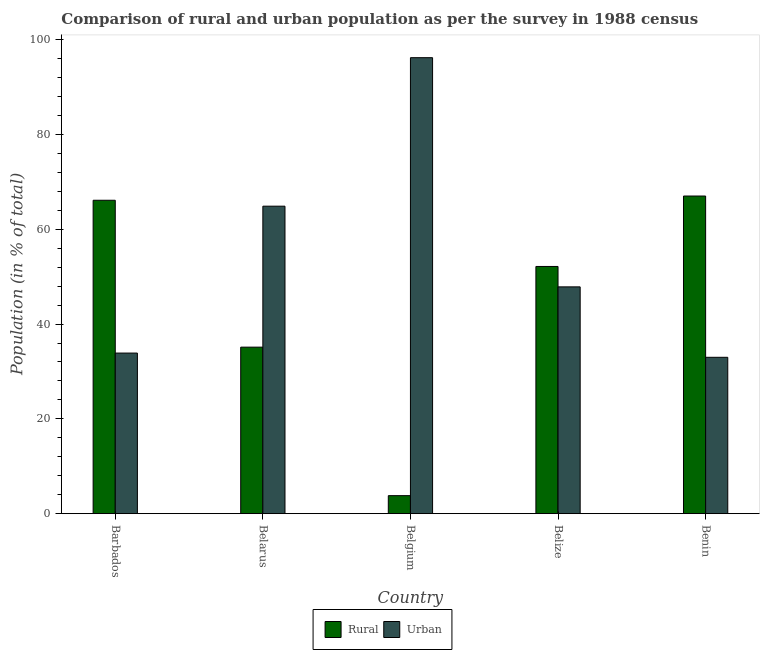How many different coloured bars are there?
Offer a very short reply. 2. How many groups of bars are there?
Provide a short and direct response. 5. What is the label of the 5th group of bars from the left?
Ensure brevity in your answer.  Benin. In how many cases, is the number of bars for a given country not equal to the number of legend labels?
Keep it short and to the point. 0. What is the rural population in Belarus?
Offer a terse response. 35.13. Across all countries, what is the maximum urban population?
Give a very brief answer. 96.2. Across all countries, what is the minimum urban population?
Your response must be concise. 32.98. In which country was the urban population maximum?
Give a very brief answer. Belgium. In which country was the urban population minimum?
Make the answer very short. Benin. What is the total urban population in the graph?
Give a very brief answer. 275.79. What is the difference between the urban population in Belize and that in Benin?
Make the answer very short. 14.86. What is the difference between the urban population in Belgium and the rural population in Barbados?
Provide a succinct answer. 30.08. What is the average urban population per country?
Your response must be concise. 55.16. What is the difference between the rural population and urban population in Belize?
Provide a short and direct response. 4.31. What is the ratio of the urban population in Belgium to that in Belize?
Make the answer very short. 2.01. Is the urban population in Belarus less than that in Belize?
Your answer should be very brief. No. What is the difference between the highest and the second highest urban population?
Keep it short and to the point. 31.33. What is the difference between the highest and the lowest rural population?
Ensure brevity in your answer.  63.22. Is the sum of the rural population in Belarus and Belize greater than the maximum urban population across all countries?
Ensure brevity in your answer.  No. What does the 1st bar from the left in Benin represents?
Offer a terse response. Rural. What does the 1st bar from the right in Barbados represents?
Give a very brief answer. Urban. What is the difference between two consecutive major ticks on the Y-axis?
Your answer should be very brief. 20. Does the graph contain any zero values?
Offer a very short reply. No. Does the graph contain grids?
Give a very brief answer. No. How many legend labels are there?
Your response must be concise. 2. How are the legend labels stacked?
Offer a very short reply. Horizontal. What is the title of the graph?
Give a very brief answer. Comparison of rural and urban population as per the survey in 1988 census. Does "Resident workers" appear as one of the legend labels in the graph?
Give a very brief answer. No. What is the label or title of the Y-axis?
Give a very brief answer. Population (in % of total). What is the Population (in % of total) in Rural in Barbados?
Keep it short and to the point. 66.12. What is the Population (in % of total) in Urban in Barbados?
Offer a terse response. 33.88. What is the Population (in % of total) of Rural in Belarus?
Provide a succinct answer. 35.13. What is the Population (in % of total) in Urban in Belarus?
Make the answer very short. 64.87. What is the Population (in % of total) in Rural in Belgium?
Make the answer very short. 3.8. What is the Population (in % of total) of Urban in Belgium?
Offer a terse response. 96.2. What is the Population (in % of total) of Rural in Belize?
Offer a terse response. 52.15. What is the Population (in % of total) of Urban in Belize?
Keep it short and to the point. 47.85. What is the Population (in % of total) in Rural in Benin?
Your answer should be very brief. 67.02. What is the Population (in % of total) of Urban in Benin?
Your answer should be very brief. 32.98. Across all countries, what is the maximum Population (in % of total) in Rural?
Provide a short and direct response. 67.02. Across all countries, what is the maximum Population (in % of total) in Urban?
Offer a terse response. 96.2. Across all countries, what is the minimum Population (in % of total) of Rural?
Your response must be concise. 3.8. Across all countries, what is the minimum Population (in % of total) in Urban?
Offer a terse response. 32.98. What is the total Population (in % of total) of Rural in the graph?
Keep it short and to the point. 224.21. What is the total Population (in % of total) of Urban in the graph?
Offer a terse response. 275.79. What is the difference between the Population (in % of total) in Rural in Barbados and that in Belarus?
Your response must be concise. 30.99. What is the difference between the Population (in % of total) of Urban in Barbados and that in Belarus?
Your answer should be compact. -30.99. What is the difference between the Population (in % of total) in Rural in Barbados and that in Belgium?
Keep it short and to the point. 62.32. What is the difference between the Population (in % of total) of Urban in Barbados and that in Belgium?
Your answer should be compact. -62.32. What is the difference between the Population (in % of total) of Rural in Barbados and that in Belize?
Your answer should be very brief. 13.97. What is the difference between the Population (in % of total) in Urban in Barbados and that in Belize?
Offer a very short reply. -13.97. What is the difference between the Population (in % of total) of Rural in Barbados and that in Benin?
Your answer should be compact. -0.9. What is the difference between the Population (in % of total) in Urban in Barbados and that in Benin?
Give a very brief answer. 0.9. What is the difference between the Population (in % of total) of Rural in Belarus and that in Belgium?
Give a very brief answer. 31.33. What is the difference between the Population (in % of total) of Urban in Belarus and that in Belgium?
Ensure brevity in your answer.  -31.33. What is the difference between the Population (in % of total) in Rural in Belarus and that in Belize?
Your answer should be compact. -17.03. What is the difference between the Population (in % of total) in Urban in Belarus and that in Belize?
Keep it short and to the point. 17.03. What is the difference between the Population (in % of total) in Rural in Belarus and that in Benin?
Make the answer very short. -31.89. What is the difference between the Population (in % of total) of Urban in Belarus and that in Benin?
Ensure brevity in your answer.  31.89. What is the difference between the Population (in % of total) of Rural in Belgium and that in Belize?
Make the answer very short. -48.36. What is the difference between the Population (in % of total) in Urban in Belgium and that in Belize?
Provide a succinct answer. 48.36. What is the difference between the Population (in % of total) of Rural in Belgium and that in Benin?
Give a very brief answer. -63.22. What is the difference between the Population (in % of total) in Urban in Belgium and that in Benin?
Offer a terse response. 63.22. What is the difference between the Population (in % of total) in Rural in Belize and that in Benin?
Provide a short and direct response. -14.86. What is the difference between the Population (in % of total) in Urban in Belize and that in Benin?
Give a very brief answer. 14.86. What is the difference between the Population (in % of total) in Rural in Barbados and the Population (in % of total) in Urban in Belarus?
Make the answer very short. 1.25. What is the difference between the Population (in % of total) of Rural in Barbados and the Population (in % of total) of Urban in Belgium?
Offer a terse response. -30.08. What is the difference between the Population (in % of total) in Rural in Barbados and the Population (in % of total) in Urban in Belize?
Give a very brief answer. 18.27. What is the difference between the Population (in % of total) in Rural in Barbados and the Population (in % of total) in Urban in Benin?
Your response must be concise. 33.13. What is the difference between the Population (in % of total) of Rural in Belarus and the Population (in % of total) of Urban in Belgium?
Provide a succinct answer. -61.08. What is the difference between the Population (in % of total) in Rural in Belarus and the Population (in % of total) in Urban in Belize?
Offer a terse response. -12.72. What is the difference between the Population (in % of total) in Rural in Belarus and the Population (in % of total) in Urban in Benin?
Provide a short and direct response. 2.14. What is the difference between the Population (in % of total) of Rural in Belgium and the Population (in % of total) of Urban in Belize?
Offer a very short reply. -44.05. What is the difference between the Population (in % of total) of Rural in Belgium and the Population (in % of total) of Urban in Benin?
Give a very brief answer. -29.19. What is the difference between the Population (in % of total) in Rural in Belize and the Population (in % of total) in Urban in Benin?
Make the answer very short. 19.17. What is the average Population (in % of total) in Rural per country?
Ensure brevity in your answer.  44.84. What is the average Population (in % of total) of Urban per country?
Your answer should be very brief. 55.16. What is the difference between the Population (in % of total) in Rural and Population (in % of total) in Urban in Barbados?
Offer a terse response. 32.24. What is the difference between the Population (in % of total) of Rural and Population (in % of total) of Urban in Belarus?
Provide a short and direct response. -29.74. What is the difference between the Population (in % of total) in Rural and Population (in % of total) in Urban in Belgium?
Ensure brevity in your answer.  -92.41. What is the difference between the Population (in % of total) in Rural and Population (in % of total) in Urban in Belize?
Your answer should be compact. 4.31. What is the difference between the Population (in % of total) in Rural and Population (in % of total) in Urban in Benin?
Your answer should be compact. 34.03. What is the ratio of the Population (in % of total) in Rural in Barbados to that in Belarus?
Give a very brief answer. 1.88. What is the ratio of the Population (in % of total) in Urban in Barbados to that in Belarus?
Provide a succinct answer. 0.52. What is the ratio of the Population (in % of total) in Rural in Barbados to that in Belgium?
Make the answer very short. 17.42. What is the ratio of the Population (in % of total) of Urban in Barbados to that in Belgium?
Your answer should be very brief. 0.35. What is the ratio of the Population (in % of total) of Rural in Barbados to that in Belize?
Offer a very short reply. 1.27. What is the ratio of the Population (in % of total) in Urban in Barbados to that in Belize?
Make the answer very short. 0.71. What is the ratio of the Population (in % of total) in Rural in Barbados to that in Benin?
Offer a terse response. 0.99. What is the ratio of the Population (in % of total) of Urban in Barbados to that in Benin?
Your answer should be very brief. 1.03. What is the ratio of the Population (in % of total) of Rural in Belarus to that in Belgium?
Your response must be concise. 9.25. What is the ratio of the Population (in % of total) of Urban in Belarus to that in Belgium?
Offer a very short reply. 0.67. What is the ratio of the Population (in % of total) in Rural in Belarus to that in Belize?
Make the answer very short. 0.67. What is the ratio of the Population (in % of total) in Urban in Belarus to that in Belize?
Make the answer very short. 1.36. What is the ratio of the Population (in % of total) in Rural in Belarus to that in Benin?
Offer a terse response. 0.52. What is the ratio of the Population (in % of total) of Urban in Belarus to that in Benin?
Your answer should be compact. 1.97. What is the ratio of the Population (in % of total) in Rural in Belgium to that in Belize?
Give a very brief answer. 0.07. What is the ratio of the Population (in % of total) of Urban in Belgium to that in Belize?
Make the answer very short. 2.01. What is the ratio of the Population (in % of total) in Rural in Belgium to that in Benin?
Your answer should be very brief. 0.06. What is the ratio of the Population (in % of total) of Urban in Belgium to that in Benin?
Your answer should be very brief. 2.92. What is the ratio of the Population (in % of total) of Rural in Belize to that in Benin?
Ensure brevity in your answer.  0.78. What is the ratio of the Population (in % of total) in Urban in Belize to that in Benin?
Keep it short and to the point. 1.45. What is the difference between the highest and the second highest Population (in % of total) in Rural?
Your response must be concise. 0.9. What is the difference between the highest and the second highest Population (in % of total) of Urban?
Ensure brevity in your answer.  31.33. What is the difference between the highest and the lowest Population (in % of total) of Rural?
Make the answer very short. 63.22. What is the difference between the highest and the lowest Population (in % of total) in Urban?
Provide a succinct answer. 63.22. 